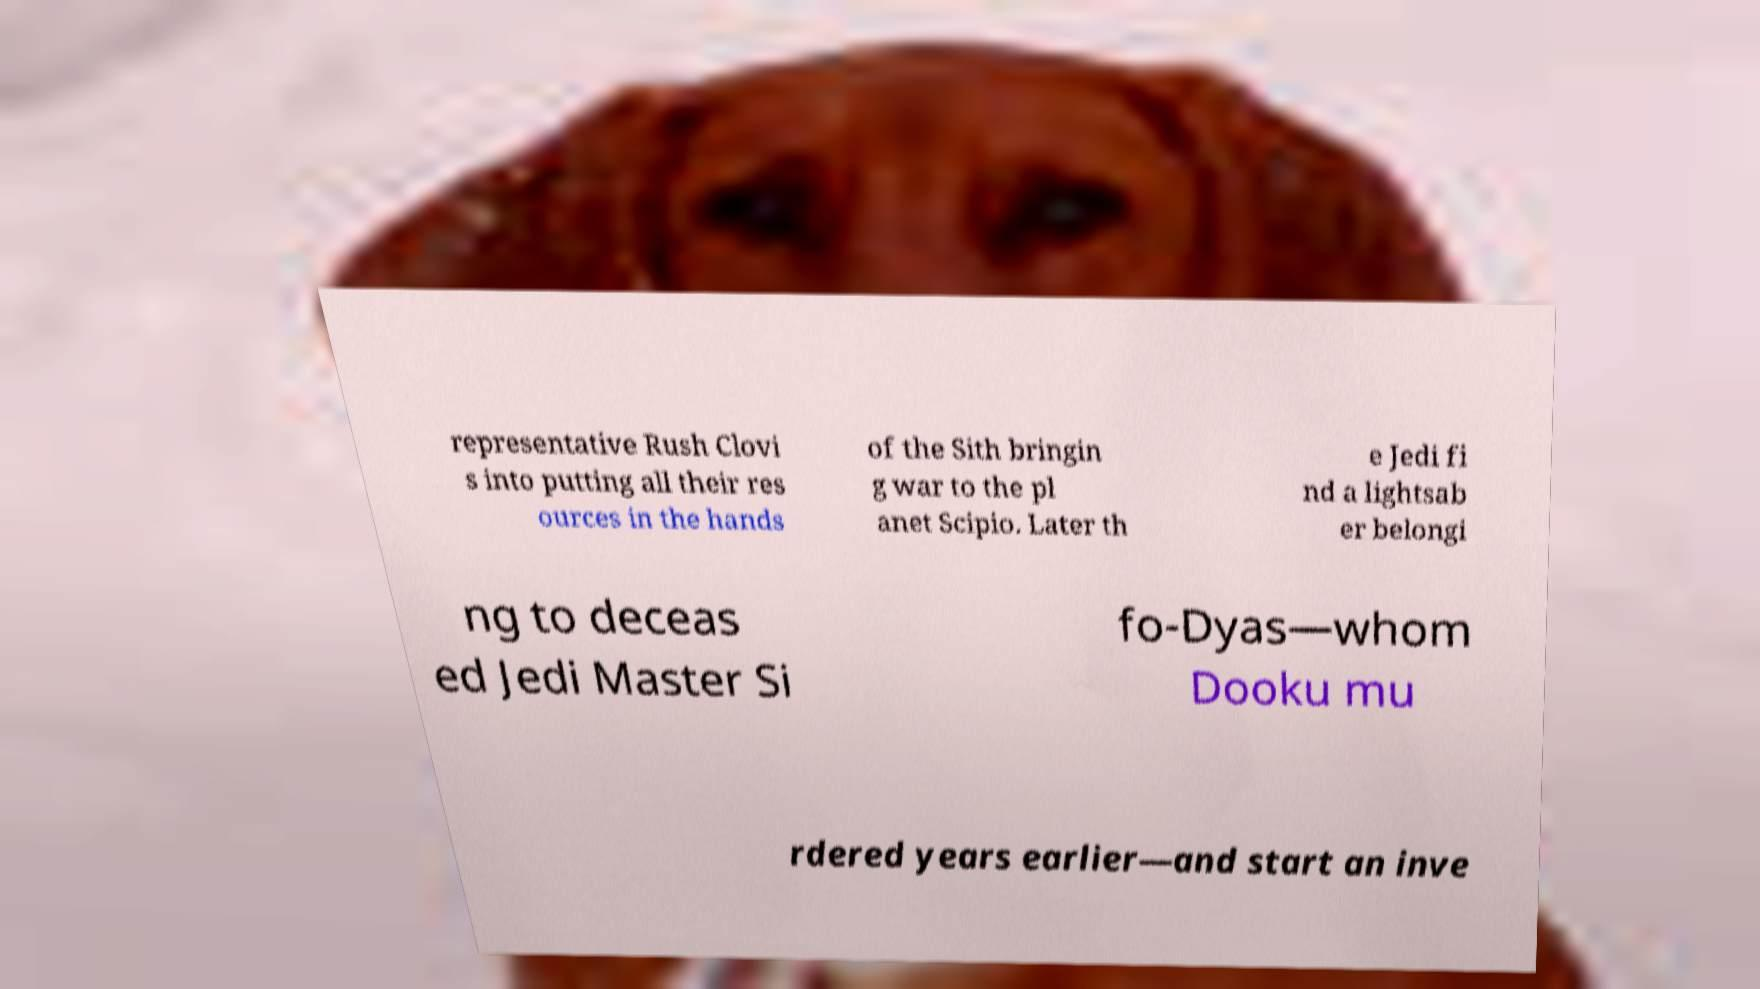Could you extract and type out the text from this image? representative Rush Clovi s into putting all their res ources in the hands of the Sith bringin g war to the pl anet Scipio. Later th e Jedi fi nd a lightsab er belongi ng to deceas ed Jedi Master Si fo-Dyas—whom Dooku mu rdered years earlier—and start an inve 